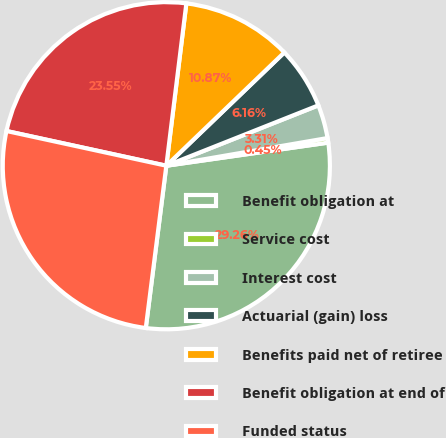Convert chart to OTSL. <chart><loc_0><loc_0><loc_500><loc_500><pie_chart><fcel>Benefit obligation at<fcel>Service cost<fcel>Interest cost<fcel>Actuarial (gain) loss<fcel>Benefits paid net of retiree<fcel>Benefit obligation at end of<fcel>Funded status<nl><fcel>29.26%<fcel>0.45%<fcel>3.31%<fcel>6.16%<fcel>10.87%<fcel>23.55%<fcel>26.4%<nl></chart> 